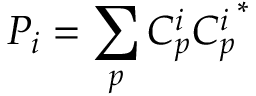<formula> <loc_0><loc_0><loc_500><loc_500>P _ { i } = \sum _ { p } C _ { p } ^ { i } { C _ { p } ^ { i } } ^ { * }</formula> 